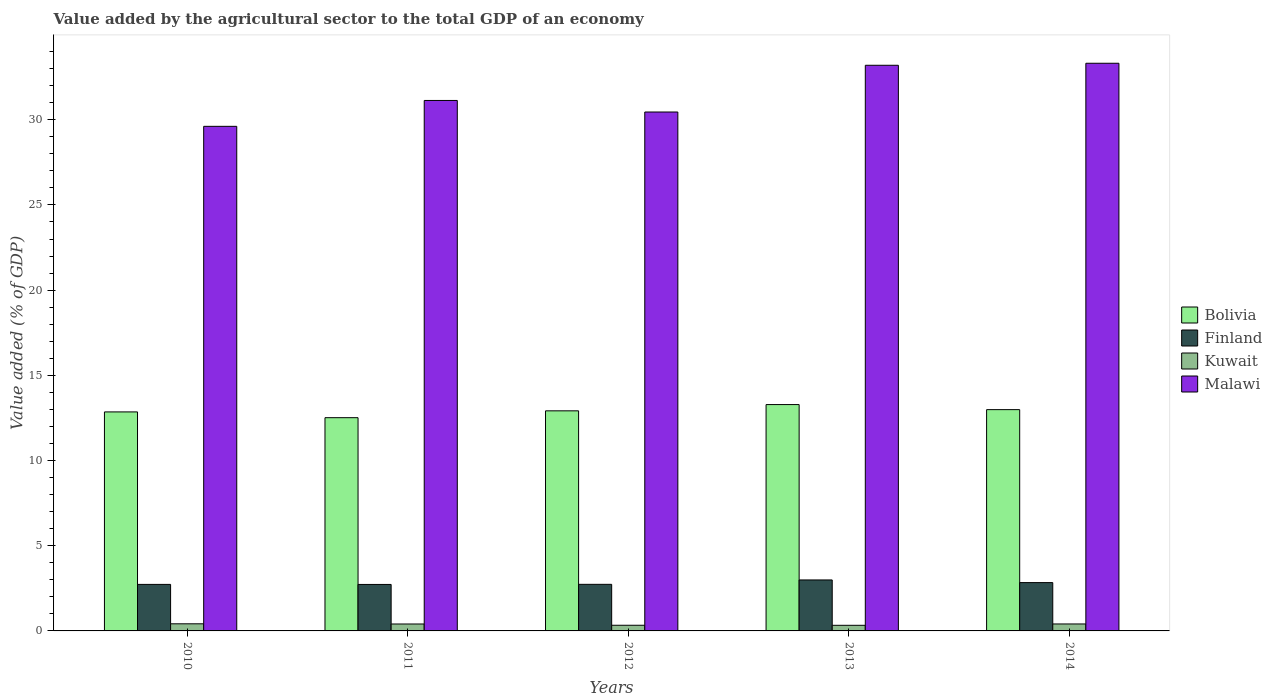How many different coloured bars are there?
Make the answer very short. 4. How many groups of bars are there?
Provide a succinct answer. 5. Are the number of bars per tick equal to the number of legend labels?
Your answer should be very brief. Yes. Are the number of bars on each tick of the X-axis equal?
Keep it short and to the point. Yes. How many bars are there on the 3rd tick from the left?
Make the answer very short. 4. What is the value added by the agricultural sector to the total GDP in Malawi in 2014?
Make the answer very short. 33.31. Across all years, what is the maximum value added by the agricultural sector to the total GDP in Kuwait?
Provide a short and direct response. 0.42. Across all years, what is the minimum value added by the agricultural sector to the total GDP in Finland?
Your response must be concise. 2.73. What is the total value added by the agricultural sector to the total GDP in Malawi in the graph?
Provide a short and direct response. 157.71. What is the difference between the value added by the agricultural sector to the total GDP in Malawi in 2012 and that in 2014?
Offer a terse response. -2.86. What is the difference between the value added by the agricultural sector to the total GDP in Kuwait in 2011 and the value added by the agricultural sector to the total GDP in Finland in 2013?
Offer a very short reply. -2.58. What is the average value added by the agricultural sector to the total GDP in Bolivia per year?
Offer a terse response. 12.91. In the year 2011, what is the difference between the value added by the agricultural sector to the total GDP in Bolivia and value added by the agricultural sector to the total GDP in Finland?
Provide a short and direct response. 9.79. In how many years, is the value added by the agricultural sector to the total GDP in Kuwait greater than 1 %?
Offer a very short reply. 0. What is the ratio of the value added by the agricultural sector to the total GDP in Kuwait in 2010 to that in 2014?
Your answer should be compact. 1.02. Is the difference between the value added by the agricultural sector to the total GDP in Bolivia in 2011 and 2014 greater than the difference between the value added by the agricultural sector to the total GDP in Finland in 2011 and 2014?
Provide a succinct answer. No. What is the difference between the highest and the second highest value added by the agricultural sector to the total GDP in Bolivia?
Offer a very short reply. 0.3. What is the difference between the highest and the lowest value added by the agricultural sector to the total GDP in Kuwait?
Offer a very short reply. 0.09. Is the sum of the value added by the agricultural sector to the total GDP in Bolivia in 2011 and 2014 greater than the maximum value added by the agricultural sector to the total GDP in Kuwait across all years?
Your response must be concise. Yes. What does the 1st bar from the right in 2011 represents?
Offer a very short reply. Malawi. How many years are there in the graph?
Your answer should be compact. 5. What is the difference between two consecutive major ticks on the Y-axis?
Keep it short and to the point. 5. Does the graph contain any zero values?
Ensure brevity in your answer.  No. How are the legend labels stacked?
Offer a terse response. Vertical. What is the title of the graph?
Provide a short and direct response. Value added by the agricultural sector to the total GDP of an economy. Does "South Sudan" appear as one of the legend labels in the graph?
Keep it short and to the point. No. What is the label or title of the Y-axis?
Your response must be concise. Value added (% of GDP). What is the Value added (% of GDP) of Bolivia in 2010?
Offer a very short reply. 12.85. What is the Value added (% of GDP) in Finland in 2010?
Your answer should be very brief. 2.73. What is the Value added (% of GDP) in Kuwait in 2010?
Make the answer very short. 0.42. What is the Value added (% of GDP) in Malawi in 2010?
Offer a very short reply. 29.61. What is the Value added (% of GDP) in Bolivia in 2011?
Give a very brief answer. 12.51. What is the Value added (% of GDP) in Finland in 2011?
Your answer should be compact. 2.73. What is the Value added (% of GDP) of Kuwait in 2011?
Your answer should be compact. 0.41. What is the Value added (% of GDP) in Malawi in 2011?
Offer a terse response. 31.13. What is the Value added (% of GDP) of Bolivia in 2012?
Your answer should be compact. 12.92. What is the Value added (% of GDP) of Finland in 2012?
Give a very brief answer. 2.73. What is the Value added (% of GDP) of Kuwait in 2012?
Your answer should be very brief. 0.33. What is the Value added (% of GDP) in Malawi in 2012?
Your answer should be very brief. 30.45. What is the Value added (% of GDP) of Bolivia in 2013?
Ensure brevity in your answer.  13.28. What is the Value added (% of GDP) in Finland in 2013?
Give a very brief answer. 2.99. What is the Value added (% of GDP) of Kuwait in 2013?
Provide a succinct answer. 0.33. What is the Value added (% of GDP) in Malawi in 2013?
Your answer should be very brief. 33.2. What is the Value added (% of GDP) in Bolivia in 2014?
Offer a very short reply. 12.99. What is the Value added (% of GDP) of Finland in 2014?
Offer a terse response. 2.84. What is the Value added (% of GDP) of Kuwait in 2014?
Offer a very short reply. 0.41. What is the Value added (% of GDP) in Malawi in 2014?
Ensure brevity in your answer.  33.31. Across all years, what is the maximum Value added (% of GDP) in Bolivia?
Keep it short and to the point. 13.28. Across all years, what is the maximum Value added (% of GDP) of Finland?
Your answer should be very brief. 2.99. Across all years, what is the maximum Value added (% of GDP) in Kuwait?
Make the answer very short. 0.42. Across all years, what is the maximum Value added (% of GDP) in Malawi?
Make the answer very short. 33.31. Across all years, what is the minimum Value added (% of GDP) in Bolivia?
Offer a terse response. 12.51. Across all years, what is the minimum Value added (% of GDP) of Finland?
Offer a terse response. 2.73. Across all years, what is the minimum Value added (% of GDP) in Kuwait?
Ensure brevity in your answer.  0.33. Across all years, what is the minimum Value added (% of GDP) of Malawi?
Keep it short and to the point. 29.61. What is the total Value added (% of GDP) of Bolivia in the graph?
Your answer should be very brief. 64.55. What is the total Value added (% of GDP) in Finland in the graph?
Ensure brevity in your answer.  14.02. What is the total Value added (% of GDP) of Kuwait in the graph?
Offer a terse response. 1.89. What is the total Value added (% of GDP) of Malawi in the graph?
Make the answer very short. 157.71. What is the difference between the Value added (% of GDP) in Bolivia in 2010 and that in 2011?
Your response must be concise. 0.34. What is the difference between the Value added (% of GDP) in Finland in 2010 and that in 2011?
Your response must be concise. 0. What is the difference between the Value added (% of GDP) of Kuwait in 2010 and that in 2011?
Give a very brief answer. 0.01. What is the difference between the Value added (% of GDP) of Malawi in 2010 and that in 2011?
Offer a very short reply. -1.52. What is the difference between the Value added (% of GDP) of Bolivia in 2010 and that in 2012?
Make the answer very short. -0.06. What is the difference between the Value added (% of GDP) of Finland in 2010 and that in 2012?
Your answer should be compact. -0. What is the difference between the Value added (% of GDP) in Kuwait in 2010 and that in 2012?
Keep it short and to the point. 0.09. What is the difference between the Value added (% of GDP) in Malawi in 2010 and that in 2012?
Provide a succinct answer. -0.84. What is the difference between the Value added (% of GDP) of Bolivia in 2010 and that in 2013?
Your response must be concise. -0.43. What is the difference between the Value added (% of GDP) of Finland in 2010 and that in 2013?
Provide a short and direct response. -0.26. What is the difference between the Value added (% of GDP) in Kuwait in 2010 and that in 2013?
Your answer should be very brief. 0.09. What is the difference between the Value added (% of GDP) of Malawi in 2010 and that in 2013?
Offer a terse response. -3.58. What is the difference between the Value added (% of GDP) of Bolivia in 2010 and that in 2014?
Your answer should be compact. -0.13. What is the difference between the Value added (% of GDP) of Finland in 2010 and that in 2014?
Offer a terse response. -0.11. What is the difference between the Value added (% of GDP) of Kuwait in 2010 and that in 2014?
Provide a short and direct response. 0.01. What is the difference between the Value added (% of GDP) in Malawi in 2010 and that in 2014?
Keep it short and to the point. -3.7. What is the difference between the Value added (% of GDP) of Bolivia in 2011 and that in 2012?
Give a very brief answer. -0.4. What is the difference between the Value added (% of GDP) in Finland in 2011 and that in 2012?
Keep it short and to the point. -0.01. What is the difference between the Value added (% of GDP) in Kuwait in 2011 and that in 2012?
Offer a terse response. 0.07. What is the difference between the Value added (% of GDP) in Malawi in 2011 and that in 2012?
Ensure brevity in your answer.  0.68. What is the difference between the Value added (% of GDP) of Bolivia in 2011 and that in 2013?
Your answer should be compact. -0.77. What is the difference between the Value added (% of GDP) in Finland in 2011 and that in 2013?
Your response must be concise. -0.26. What is the difference between the Value added (% of GDP) in Kuwait in 2011 and that in 2013?
Provide a short and direct response. 0.08. What is the difference between the Value added (% of GDP) in Malawi in 2011 and that in 2013?
Your answer should be compact. -2.06. What is the difference between the Value added (% of GDP) in Bolivia in 2011 and that in 2014?
Your response must be concise. -0.47. What is the difference between the Value added (% of GDP) in Finland in 2011 and that in 2014?
Provide a short and direct response. -0.11. What is the difference between the Value added (% of GDP) of Kuwait in 2011 and that in 2014?
Provide a succinct answer. -0. What is the difference between the Value added (% of GDP) in Malawi in 2011 and that in 2014?
Keep it short and to the point. -2.18. What is the difference between the Value added (% of GDP) of Bolivia in 2012 and that in 2013?
Make the answer very short. -0.37. What is the difference between the Value added (% of GDP) in Finland in 2012 and that in 2013?
Provide a succinct answer. -0.26. What is the difference between the Value added (% of GDP) in Kuwait in 2012 and that in 2013?
Ensure brevity in your answer.  0. What is the difference between the Value added (% of GDP) of Malawi in 2012 and that in 2013?
Your answer should be compact. -2.74. What is the difference between the Value added (% of GDP) in Bolivia in 2012 and that in 2014?
Give a very brief answer. -0.07. What is the difference between the Value added (% of GDP) of Finland in 2012 and that in 2014?
Offer a terse response. -0.1. What is the difference between the Value added (% of GDP) in Kuwait in 2012 and that in 2014?
Your answer should be very brief. -0.08. What is the difference between the Value added (% of GDP) in Malawi in 2012 and that in 2014?
Make the answer very short. -2.86. What is the difference between the Value added (% of GDP) of Bolivia in 2013 and that in 2014?
Offer a terse response. 0.3. What is the difference between the Value added (% of GDP) of Finland in 2013 and that in 2014?
Offer a very short reply. 0.16. What is the difference between the Value added (% of GDP) in Kuwait in 2013 and that in 2014?
Keep it short and to the point. -0.08. What is the difference between the Value added (% of GDP) of Malawi in 2013 and that in 2014?
Provide a short and direct response. -0.12. What is the difference between the Value added (% of GDP) in Bolivia in 2010 and the Value added (% of GDP) in Finland in 2011?
Your response must be concise. 10.13. What is the difference between the Value added (% of GDP) in Bolivia in 2010 and the Value added (% of GDP) in Kuwait in 2011?
Your answer should be compact. 12.45. What is the difference between the Value added (% of GDP) of Bolivia in 2010 and the Value added (% of GDP) of Malawi in 2011?
Your answer should be compact. -18.28. What is the difference between the Value added (% of GDP) in Finland in 2010 and the Value added (% of GDP) in Kuwait in 2011?
Your answer should be very brief. 2.32. What is the difference between the Value added (% of GDP) in Finland in 2010 and the Value added (% of GDP) in Malawi in 2011?
Provide a short and direct response. -28.4. What is the difference between the Value added (% of GDP) of Kuwait in 2010 and the Value added (% of GDP) of Malawi in 2011?
Keep it short and to the point. -30.71. What is the difference between the Value added (% of GDP) of Bolivia in 2010 and the Value added (% of GDP) of Finland in 2012?
Your answer should be very brief. 10.12. What is the difference between the Value added (% of GDP) in Bolivia in 2010 and the Value added (% of GDP) in Kuwait in 2012?
Give a very brief answer. 12.52. What is the difference between the Value added (% of GDP) in Bolivia in 2010 and the Value added (% of GDP) in Malawi in 2012?
Your answer should be very brief. -17.6. What is the difference between the Value added (% of GDP) in Finland in 2010 and the Value added (% of GDP) in Kuwait in 2012?
Provide a succinct answer. 2.4. What is the difference between the Value added (% of GDP) of Finland in 2010 and the Value added (% of GDP) of Malawi in 2012?
Provide a short and direct response. -27.72. What is the difference between the Value added (% of GDP) in Kuwait in 2010 and the Value added (% of GDP) in Malawi in 2012?
Offer a very short reply. -30.04. What is the difference between the Value added (% of GDP) in Bolivia in 2010 and the Value added (% of GDP) in Finland in 2013?
Give a very brief answer. 9.86. What is the difference between the Value added (% of GDP) in Bolivia in 2010 and the Value added (% of GDP) in Kuwait in 2013?
Keep it short and to the point. 12.52. What is the difference between the Value added (% of GDP) of Bolivia in 2010 and the Value added (% of GDP) of Malawi in 2013?
Keep it short and to the point. -20.34. What is the difference between the Value added (% of GDP) in Finland in 2010 and the Value added (% of GDP) in Kuwait in 2013?
Offer a very short reply. 2.4. What is the difference between the Value added (% of GDP) in Finland in 2010 and the Value added (% of GDP) in Malawi in 2013?
Make the answer very short. -30.47. What is the difference between the Value added (% of GDP) in Kuwait in 2010 and the Value added (% of GDP) in Malawi in 2013?
Your response must be concise. -32.78. What is the difference between the Value added (% of GDP) of Bolivia in 2010 and the Value added (% of GDP) of Finland in 2014?
Your answer should be very brief. 10.02. What is the difference between the Value added (% of GDP) in Bolivia in 2010 and the Value added (% of GDP) in Kuwait in 2014?
Provide a short and direct response. 12.44. What is the difference between the Value added (% of GDP) in Bolivia in 2010 and the Value added (% of GDP) in Malawi in 2014?
Offer a terse response. -20.46. What is the difference between the Value added (% of GDP) of Finland in 2010 and the Value added (% of GDP) of Kuwait in 2014?
Make the answer very short. 2.32. What is the difference between the Value added (% of GDP) in Finland in 2010 and the Value added (% of GDP) in Malawi in 2014?
Your answer should be compact. -30.58. What is the difference between the Value added (% of GDP) of Kuwait in 2010 and the Value added (% of GDP) of Malawi in 2014?
Make the answer very short. -32.9. What is the difference between the Value added (% of GDP) in Bolivia in 2011 and the Value added (% of GDP) in Finland in 2012?
Provide a short and direct response. 9.78. What is the difference between the Value added (% of GDP) in Bolivia in 2011 and the Value added (% of GDP) in Kuwait in 2012?
Offer a very short reply. 12.18. What is the difference between the Value added (% of GDP) in Bolivia in 2011 and the Value added (% of GDP) in Malawi in 2012?
Provide a short and direct response. -17.94. What is the difference between the Value added (% of GDP) in Finland in 2011 and the Value added (% of GDP) in Kuwait in 2012?
Provide a succinct answer. 2.4. What is the difference between the Value added (% of GDP) of Finland in 2011 and the Value added (% of GDP) of Malawi in 2012?
Ensure brevity in your answer.  -27.73. What is the difference between the Value added (% of GDP) of Kuwait in 2011 and the Value added (% of GDP) of Malawi in 2012?
Provide a short and direct response. -30.05. What is the difference between the Value added (% of GDP) of Bolivia in 2011 and the Value added (% of GDP) of Finland in 2013?
Ensure brevity in your answer.  9.52. What is the difference between the Value added (% of GDP) in Bolivia in 2011 and the Value added (% of GDP) in Kuwait in 2013?
Your response must be concise. 12.18. What is the difference between the Value added (% of GDP) of Bolivia in 2011 and the Value added (% of GDP) of Malawi in 2013?
Make the answer very short. -20.68. What is the difference between the Value added (% of GDP) in Finland in 2011 and the Value added (% of GDP) in Kuwait in 2013?
Offer a terse response. 2.4. What is the difference between the Value added (% of GDP) in Finland in 2011 and the Value added (% of GDP) in Malawi in 2013?
Give a very brief answer. -30.47. What is the difference between the Value added (% of GDP) of Kuwait in 2011 and the Value added (% of GDP) of Malawi in 2013?
Your answer should be compact. -32.79. What is the difference between the Value added (% of GDP) of Bolivia in 2011 and the Value added (% of GDP) of Finland in 2014?
Give a very brief answer. 9.68. What is the difference between the Value added (% of GDP) of Bolivia in 2011 and the Value added (% of GDP) of Kuwait in 2014?
Your response must be concise. 12.11. What is the difference between the Value added (% of GDP) of Bolivia in 2011 and the Value added (% of GDP) of Malawi in 2014?
Provide a succinct answer. -20.8. What is the difference between the Value added (% of GDP) of Finland in 2011 and the Value added (% of GDP) of Kuwait in 2014?
Provide a succinct answer. 2.32. What is the difference between the Value added (% of GDP) of Finland in 2011 and the Value added (% of GDP) of Malawi in 2014?
Offer a very short reply. -30.59. What is the difference between the Value added (% of GDP) in Kuwait in 2011 and the Value added (% of GDP) in Malawi in 2014?
Offer a terse response. -32.91. What is the difference between the Value added (% of GDP) in Bolivia in 2012 and the Value added (% of GDP) in Finland in 2013?
Your answer should be compact. 9.92. What is the difference between the Value added (% of GDP) in Bolivia in 2012 and the Value added (% of GDP) in Kuwait in 2013?
Provide a short and direct response. 12.59. What is the difference between the Value added (% of GDP) in Bolivia in 2012 and the Value added (% of GDP) in Malawi in 2013?
Your answer should be compact. -20.28. What is the difference between the Value added (% of GDP) in Finland in 2012 and the Value added (% of GDP) in Kuwait in 2013?
Your answer should be very brief. 2.4. What is the difference between the Value added (% of GDP) of Finland in 2012 and the Value added (% of GDP) of Malawi in 2013?
Provide a short and direct response. -30.46. What is the difference between the Value added (% of GDP) in Kuwait in 2012 and the Value added (% of GDP) in Malawi in 2013?
Your answer should be compact. -32.86. What is the difference between the Value added (% of GDP) in Bolivia in 2012 and the Value added (% of GDP) in Finland in 2014?
Keep it short and to the point. 10.08. What is the difference between the Value added (% of GDP) of Bolivia in 2012 and the Value added (% of GDP) of Kuwait in 2014?
Keep it short and to the point. 12.51. What is the difference between the Value added (% of GDP) in Bolivia in 2012 and the Value added (% of GDP) in Malawi in 2014?
Make the answer very short. -20.4. What is the difference between the Value added (% of GDP) of Finland in 2012 and the Value added (% of GDP) of Kuwait in 2014?
Provide a succinct answer. 2.33. What is the difference between the Value added (% of GDP) in Finland in 2012 and the Value added (% of GDP) in Malawi in 2014?
Offer a very short reply. -30.58. What is the difference between the Value added (% of GDP) in Kuwait in 2012 and the Value added (% of GDP) in Malawi in 2014?
Ensure brevity in your answer.  -32.98. What is the difference between the Value added (% of GDP) of Bolivia in 2013 and the Value added (% of GDP) of Finland in 2014?
Ensure brevity in your answer.  10.45. What is the difference between the Value added (% of GDP) in Bolivia in 2013 and the Value added (% of GDP) in Kuwait in 2014?
Ensure brevity in your answer.  12.88. What is the difference between the Value added (% of GDP) of Bolivia in 2013 and the Value added (% of GDP) of Malawi in 2014?
Make the answer very short. -20.03. What is the difference between the Value added (% of GDP) of Finland in 2013 and the Value added (% of GDP) of Kuwait in 2014?
Offer a terse response. 2.58. What is the difference between the Value added (% of GDP) in Finland in 2013 and the Value added (% of GDP) in Malawi in 2014?
Provide a short and direct response. -30.32. What is the difference between the Value added (% of GDP) in Kuwait in 2013 and the Value added (% of GDP) in Malawi in 2014?
Keep it short and to the point. -32.98. What is the average Value added (% of GDP) in Bolivia per year?
Offer a very short reply. 12.91. What is the average Value added (% of GDP) in Finland per year?
Your response must be concise. 2.8. What is the average Value added (% of GDP) in Kuwait per year?
Your answer should be very brief. 0.38. What is the average Value added (% of GDP) of Malawi per year?
Keep it short and to the point. 31.54. In the year 2010, what is the difference between the Value added (% of GDP) of Bolivia and Value added (% of GDP) of Finland?
Your response must be concise. 10.12. In the year 2010, what is the difference between the Value added (% of GDP) in Bolivia and Value added (% of GDP) in Kuwait?
Keep it short and to the point. 12.44. In the year 2010, what is the difference between the Value added (% of GDP) of Bolivia and Value added (% of GDP) of Malawi?
Give a very brief answer. -16.76. In the year 2010, what is the difference between the Value added (% of GDP) in Finland and Value added (% of GDP) in Kuwait?
Offer a terse response. 2.31. In the year 2010, what is the difference between the Value added (% of GDP) in Finland and Value added (% of GDP) in Malawi?
Your answer should be very brief. -26.88. In the year 2010, what is the difference between the Value added (% of GDP) of Kuwait and Value added (% of GDP) of Malawi?
Ensure brevity in your answer.  -29.2. In the year 2011, what is the difference between the Value added (% of GDP) in Bolivia and Value added (% of GDP) in Finland?
Offer a very short reply. 9.79. In the year 2011, what is the difference between the Value added (% of GDP) in Bolivia and Value added (% of GDP) in Kuwait?
Ensure brevity in your answer.  12.11. In the year 2011, what is the difference between the Value added (% of GDP) of Bolivia and Value added (% of GDP) of Malawi?
Give a very brief answer. -18.62. In the year 2011, what is the difference between the Value added (% of GDP) of Finland and Value added (% of GDP) of Kuwait?
Ensure brevity in your answer.  2.32. In the year 2011, what is the difference between the Value added (% of GDP) of Finland and Value added (% of GDP) of Malawi?
Give a very brief answer. -28.4. In the year 2011, what is the difference between the Value added (% of GDP) of Kuwait and Value added (% of GDP) of Malawi?
Keep it short and to the point. -30.72. In the year 2012, what is the difference between the Value added (% of GDP) in Bolivia and Value added (% of GDP) in Finland?
Offer a terse response. 10.18. In the year 2012, what is the difference between the Value added (% of GDP) in Bolivia and Value added (% of GDP) in Kuwait?
Offer a terse response. 12.58. In the year 2012, what is the difference between the Value added (% of GDP) in Bolivia and Value added (% of GDP) in Malawi?
Keep it short and to the point. -17.54. In the year 2012, what is the difference between the Value added (% of GDP) of Finland and Value added (% of GDP) of Kuwait?
Provide a short and direct response. 2.4. In the year 2012, what is the difference between the Value added (% of GDP) in Finland and Value added (% of GDP) in Malawi?
Ensure brevity in your answer.  -27.72. In the year 2012, what is the difference between the Value added (% of GDP) in Kuwait and Value added (% of GDP) in Malawi?
Provide a succinct answer. -30.12. In the year 2013, what is the difference between the Value added (% of GDP) in Bolivia and Value added (% of GDP) in Finland?
Your response must be concise. 10.29. In the year 2013, what is the difference between the Value added (% of GDP) in Bolivia and Value added (% of GDP) in Kuwait?
Keep it short and to the point. 12.95. In the year 2013, what is the difference between the Value added (% of GDP) in Bolivia and Value added (% of GDP) in Malawi?
Ensure brevity in your answer.  -19.91. In the year 2013, what is the difference between the Value added (% of GDP) of Finland and Value added (% of GDP) of Kuwait?
Your response must be concise. 2.66. In the year 2013, what is the difference between the Value added (% of GDP) in Finland and Value added (% of GDP) in Malawi?
Give a very brief answer. -30.2. In the year 2013, what is the difference between the Value added (% of GDP) of Kuwait and Value added (% of GDP) of Malawi?
Your response must be concise. -32.87. In the year 2014, what is the difference between the Value added (% of GDP) in Bolivia and Value added (% of GDP) in Finland?
Offer a terse response. 10.15. In the year 2014, what is the difference between the Value added (% of GDP) in Bolivia and Value added (% of GDP) in Kuwait?
Make the answer very short. 12.58. In the year 2014, what is the difference between the Value added (% of GDP) of Bolivia and Value added (% of GDP) of Malawi?
Keep it short and to the point. -20.33. In the year 2014, what is the difference between the Value added (% of GDP) in Finland and Value added (% of GDP) in Kuwait?
Offer a very short reply. 2.43. In the year 2014, what is the difference between the Value added (% of GDP) of Finland and Value added (% of GDP) of Malawi?
Ensure brevity in your answer.  -30.48. In the year 2014, what is the difference between the Value added (% of GDP) of Kuwait and Value added (% of GDP) of Malawi?
Your answer should be compact. -32.91. What is the ratio of the Value added (% of GDP) in Bolivia in 2010 to that in 2011?
Ensure brevity in your answer.  1.03. What is the ratio of the Value added (% of GDP) in Finland in 2010 to that in 2011?
Make the answer very short. 1. What is the ratio of the Value added (% of GDP) of Kuwait in 2010 to that in 2011?
Provide a short and direct response. 1.03. What is the ratio of the Value added (% of GDP) in Malawi in 2010 to that in 2011?
Ensure brevity in your answer.  0.95. What is the ratio of the Value added (% of GDP) of Kuwait in 2010 to that in 2012?
Provide a succinct answer. 1.26. What is the ratio of the Value added (% of GDP) of Malawi in 2010 to that in 2012?
Make the answer very short. 0.97. What is the ratio of the Value added (% of GDP) in Bolivia in 2010 to that in 2013?
Ensure brevity in your answer.  0.97. What is the ratio of the Value added (% of GDP) of Finland in 2010 to that in 2013?
Your response must be concise. 0.91. What is the ratio of the Value added (% of GDP) of Kuwait in 2010 to that in 2013?
Keep it short and to the point. 1.26. What is the ratio of the Value added (% of GDP) in Malawi in 2010 to that in 2013?
Your response must be concise. 0.89. What is the ratio of the Value added (% of GDP) in Bolivia in 2010 to that in 2014?
Offer a terse response. 0.99. What is the ratio of the Value added (% of GDP) in Finland in 2010 to that in 2014?
Provide a short and direct response. 0.96. What is the ratio of the Value added (% of GDP) of Kuwait in 2010 to that in 2014?
Your answer should be very brief. 1.02. What is the ratio of the Value added (% of GDP) of Bolivia in 2011 to that in 2012?
Your answer should be very brief. 0.97. What is the ratio of the Value added (% of GDP) of Finland in 2011 to that in 2012?
Keep it short and to the point. 1. What is the ratio of the Value added (% of GDP) in Kuwait in 2011 to that in 2012?
Offer a very short reply. 1.22. What is the ratio of the Value added (% of GDP) in Malawi in 2011 to that in 2012?
Your response must be concise. 1.02. What is the ratio of the Value added (% of GDP) of Bolivia in 2011 to that in 2013?
Offer a very short reply. 0.94. What is the ratio of the Value added (% of GDP) of Finland in 2011 to that in 2013?
Provide a succinct answer. 0.91. What is the ratio of the Value added (% of GDP) in Kuwait in 2011 to that in 2013?
Your response must be concise. 1.23. What is the ratio of the Value added (% of GDP) in Malawi in 2011 to that in 2013?
Offer a terse response. 0.94. What is the ratio of the Value added (% of GDP) of Bolivia in 2011 to that in 2014?
Make the answer very short. 0.96. What is the ratio of the Value added (% of GDP) in Finland in 2011 to that in 2014?
Your response must be concise. 0.96. What is the ratio of the Value added (% of GDP) of Kuwait in 2011 to that in 2014?
Ensure brevity in your answer.  1. What is the ratio of the Value added (% of GDP) in Malawi in 2011 to that in 2014?
Keep it short and to the point. 0.93. What is the ratio of the Value added (% of GDP) of Bolivia in 2012 to that in 2013?
Your answer should be very brief. 0.97. What is the ratio of the Value added (% of GDP) of Finland in 2012 to that in 2013?
Offer a terse response. 0.91. What is the ratio of the Value added (% of GDP) of Kuwait in 2012 to that in 2013?
Offer a very short reply. 1.01. What is the ratio of the Value added (% of GDP) of Malawi in 2012 to that in 2013?
Provide a short and direct response. 0.92. What is the ratio of the Value added (% of GDP) of Bolivia in 2012 to that in 2014?
Your response must be concise. 0.99. What is the ratio of the Value added (% of GDP) of Finland in 2012 to that in 2014?
Keep it short and to the point. 0.96. What is the ratio of the Value added (% of GDP) of Kuwait in 2012 to that in 2014?
Offer a terse response. 0.81. What is the ratio of the Value added (% of GDP) of Malawi in 2012 to that in 2014?
Provide a succinct answer. 0.91. What is the ratio of the Value added (% of GDP) in Bolivia in 2013 to that in 2014?
Provide a succinct answer. 1.02. What is the ratio of the Value added (% of GDP) of Finland in 2013 to that in 2014?
Provide a short and direct response. 1.05. What is the ratio of the Value added (% of GDP) in Kuwait in 2013 to that in 2014?
Give a very brief answer. 0.81. What is the difference between the highest and the second highest Value added (% of GDP) of Bolivia?
Your answer should be very brief. 0.3. What is the difference between the highest and the second highest Value added (% of GDP) in Finland?
Ensure brevity in your answer.  0.16. What is the difference between the highest and the second highest Value added (% of GDP) in Kuwait?
Offer a terse response. 0.01. What is the difference between the highest and the second highest Value added (% of GDP) in Malawi?
Offer a very short reply. 0.12. What is the difference between the highest and the lowest Value added (% of GDP) of Bolivia?
Your answer should be compact. 0.77. What is the difference between the highest and the lowest Value added (% of GDP) of Finland?
Your response must be concise. 0.26. What is the difference between the highest and the lowest Value added (% of GDP) in Kuwait?
Your answer should be very brief. 0.09. What is the difference between the highest and the lowest Value added (% of GDP) of Malawi?
Your response must be concise. 3.7. 